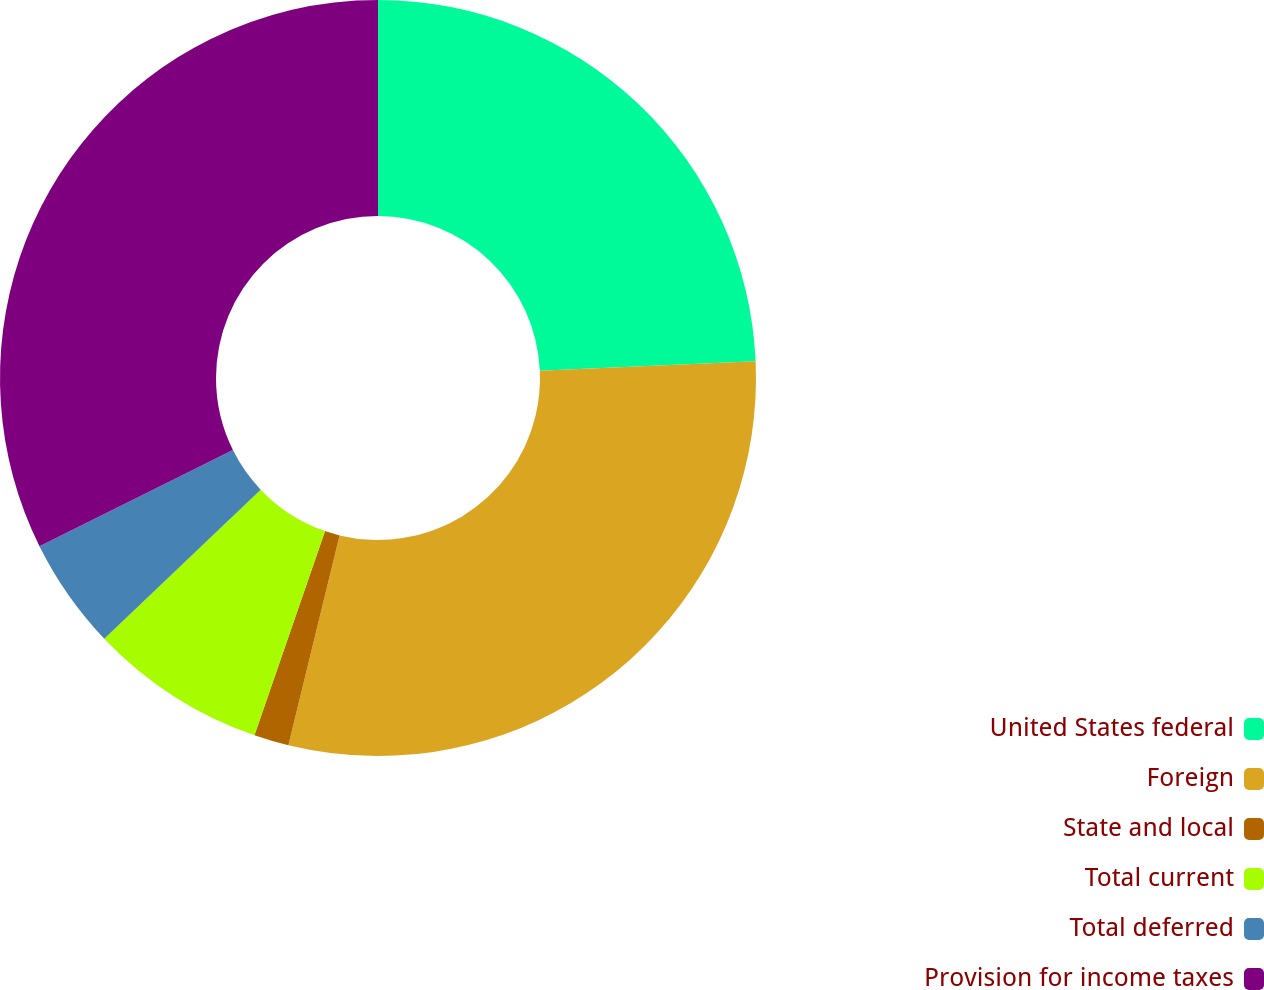<chart> <loc_0><loc_0><loc_500><loc_500><pie_chart><fcel>United States federal<fcel>Foreign<fcel>State and local<fcel>Total current<fcel>Total deferred<fcel>Provision for income taxes<nl><fcel>24.29%<fcel>29.52%<fcel>1.49%<fcel>7.59%<fcel>4.77%<fcel>32.34%<nl></chart> 